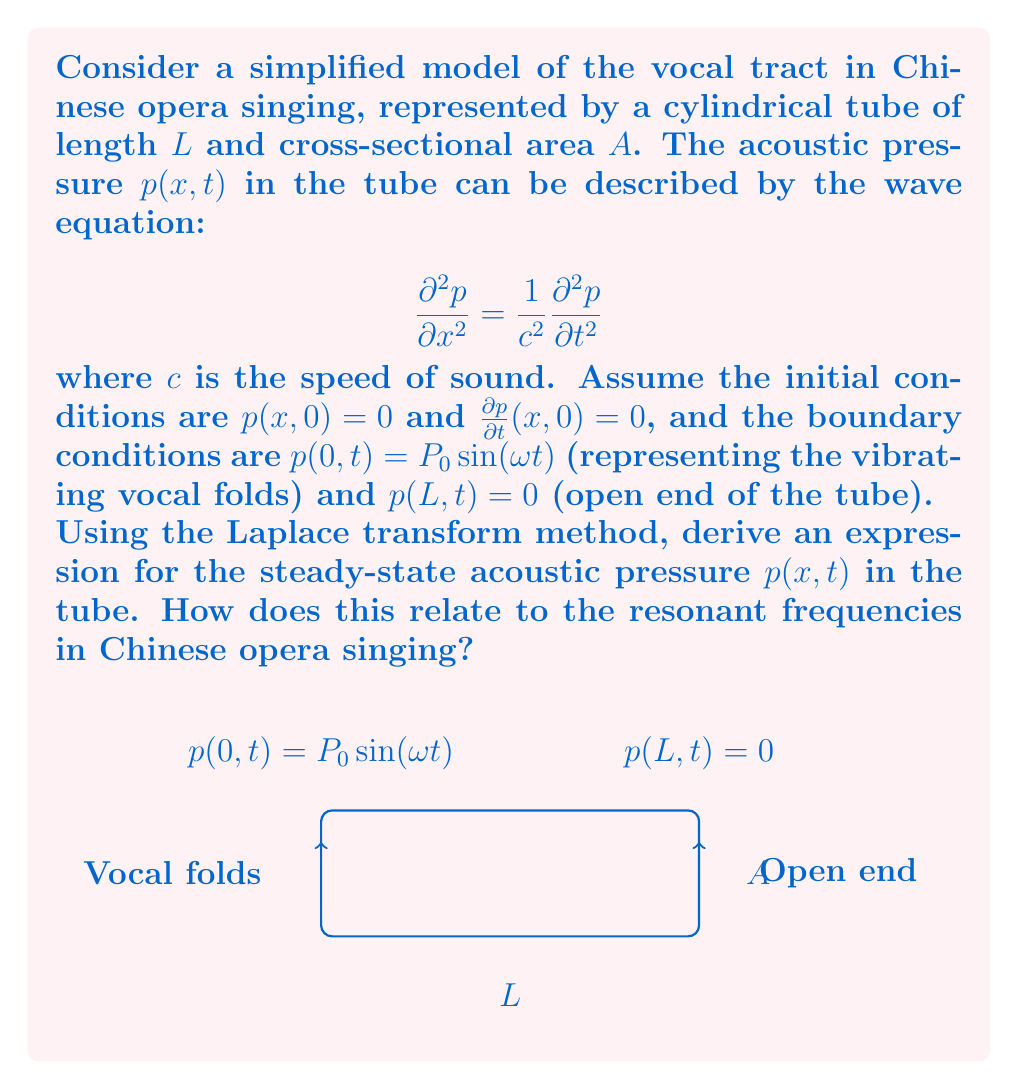What is the answer to this math problem? Let's solve this problem step by step using the Laplace transform method:

1) First, apply the Laplace transform to the wave equation with respect to t:

   $$\frac{d^2 \bar{p}}{dx^2} = \frac{s^2}{c^2}\bar{p}$$

   where $\bar{p}(x,s)$ is the Laplace transform of $p(x,t)$.

2) The general solution to this ordinary differential equation is:

   $$\bar{p}(x,s) = A(s)\cosh(\frac{sx}{c}) + B(s)\sinh(\frac{sx}{c})$$

3) Now, apply the Laplace transform to the boundary conditions:

   At $x = 0$: $\bar{p}(0,s) = \frac{P_0\omega}{s^2 + \omega^2}$
   At $x = L$: $\bar{p}(L,s) = 0$

4) Use these conditions to solve for $A(s)$ and $B(s)$:

   $A(s) = \frac{P_0\omega}{s^2 + \omega^2}$
   $B(s) = -A(s)\tanh(\frac{sL}{c})$

5) Substitute these back into the general solution:

   $$\bar{p}(x,s) = \frac{P_0\omega}{s^2 + \omega^2}\left[\cosh(\frac{sx}{c}) - \tanh(\frac{sL}{c})\sinh(\frac{sx}{c})\right]$$

6) To find the steady-state solution, we need to find the inverse Laplace transform of this expression as $s \to i\omega$:

   $$p(x,t) = P_0\frac{\sin(\omega(L-x)/c)}{\sin(\omega L/c)}\sin(\omega t)$$

7) The resonant frequencies occur when $\sin(\omega L/c) = 0$, i.e., when:

   $$\omega_n = \frac{n\pi c}{L}, \quad n = 1, 2, 3, ...$$

These resonant frequencies correspond to the formants in Chinese opera singing. Different singing styles emphasize different formants, creating unique timbres. For example, Beijing opera often emphasizes higher formants, resulting in a bright, piercing sound.
Answer: $p(x,t) = P_0\frac{\sin(\omega(L-x)/c)}{\sin(\omega L/c)}\sin(\omega t)$; Resonant frequencies: $\omega_n = \frac{n\pi c}{L}, n = 1, 2, 3, ...$ 